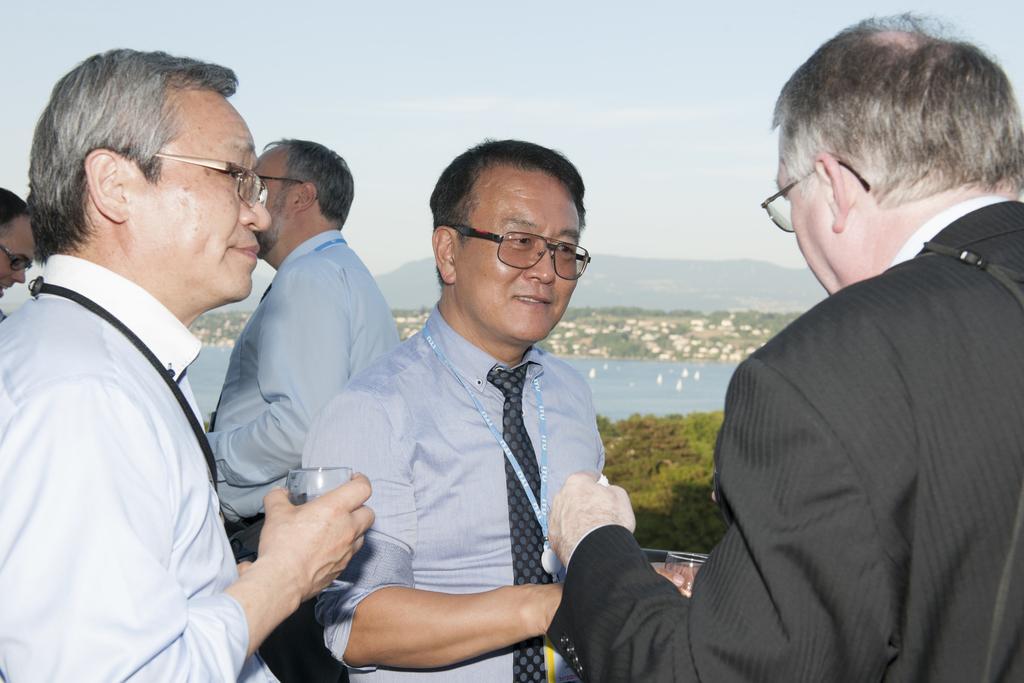Can you describe this image briefly? In this image we can see people standing and holding glasses. In the background there is water, hills, trees and sky. 